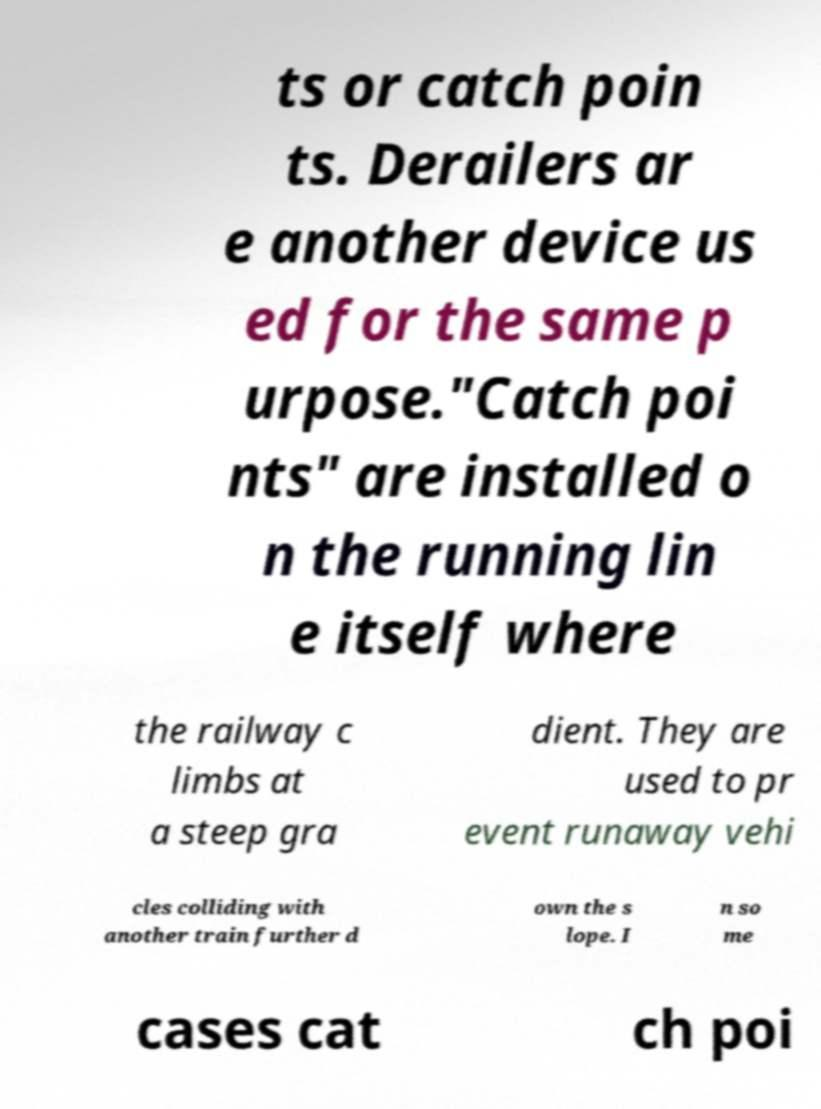Please identify and transcribe the text found in this image. ts or catch poin ts. Derailers ar e another device us ed for the same p urpose."Catch poi nts" are installed o n the running lin e itself where the railway c limbs at a steep gra dient. They are used to pr event runaway vehi cles colliding with another train further d own the s lope. I n so me cases cat ch poi 